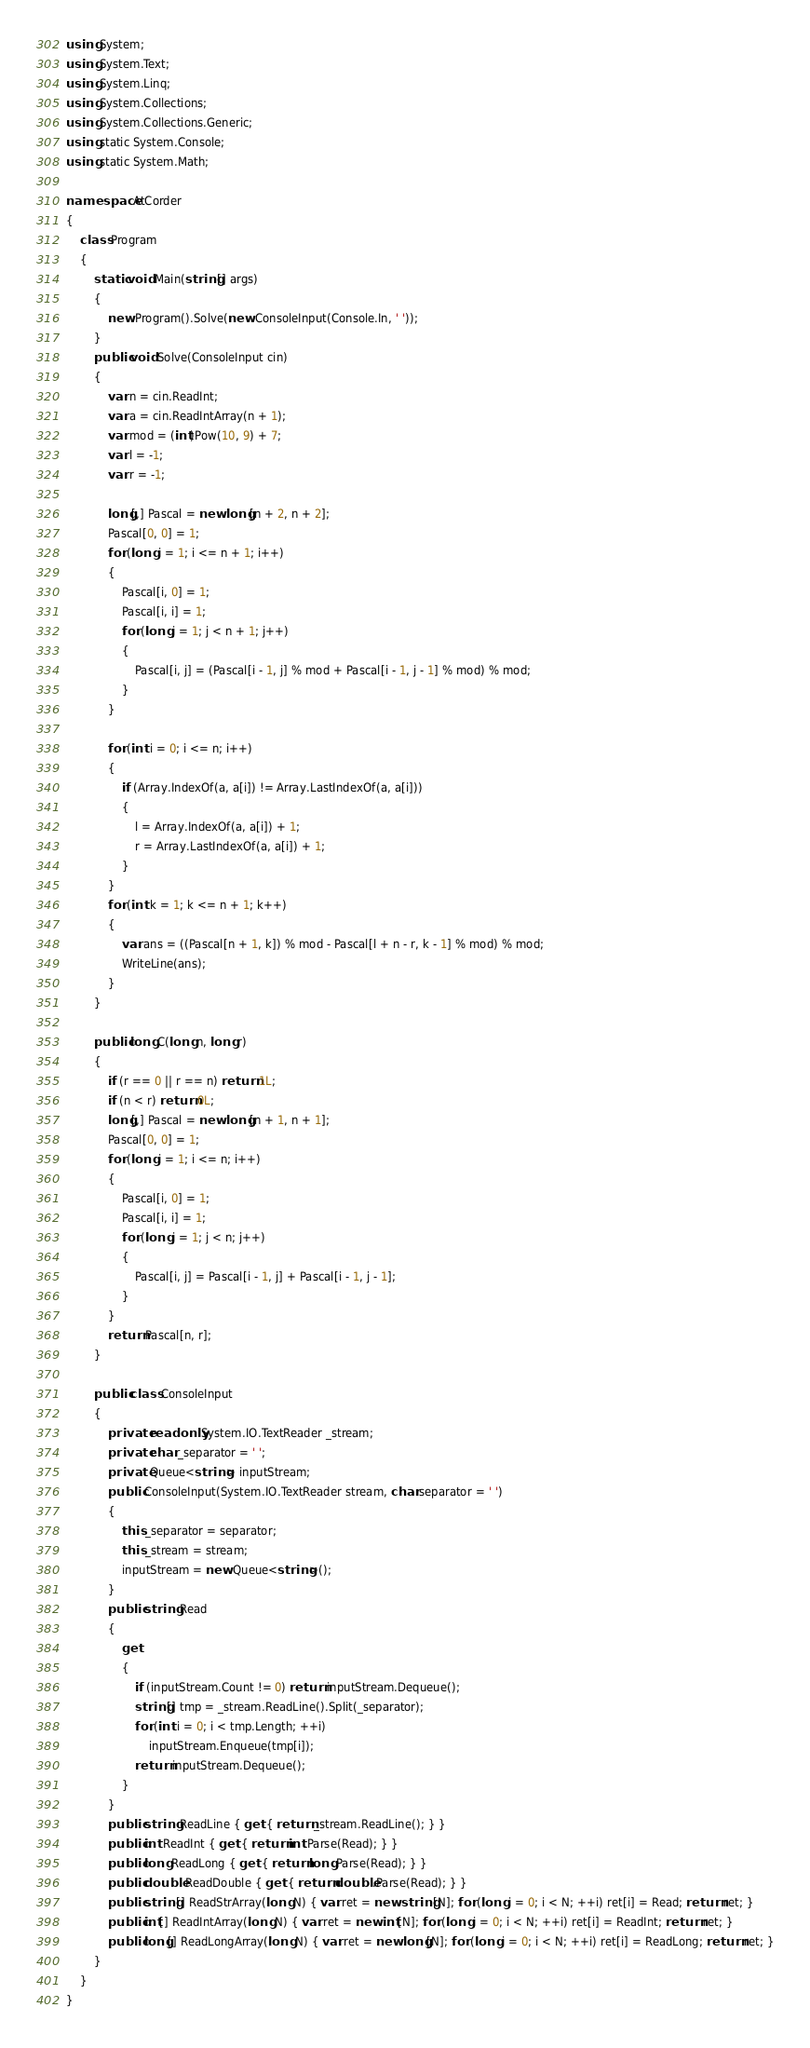Convert code to text. <code><loc_0><loc_0><loc_500><loc_500><_C#_>using System;
using System.Text;
using System.Linq;
using System.Collections;
using System.Collections.Generic;
using static System.Console;
using static System.Math;

namespace AtCorder
{
    class Program
    {
        static void Main(string[] args)
        {
            new Program().Solve(new ConsoleInput(Console.In, ' '));
        }
        public void Solve(ConsoleInput cin)
        {
            var n = cin.ReadInt;
            var a = cin.ReadIntArray(n + 1);
            var mod = (int)Pow(10, 9) + 7;
            var l = -1;
            var r = -1;

            long[,] Pascal = new long[n + 2, n + 2];
            Pascal[0, 0] = 1;
            for (long i = 1; i <= n + 1; i++)
            {
                Pascal[i, 0] = 1;
                Pascal[i, i] = 1;
                for (long j = 1; j < n + 1; j++)
                {
                    Pascal[i, j] = (Pascal[i - 1, j] % mod + Pascal[i - 1, j - 1] % mod) % mod;
                }
            }

            for (int i = 0; i <= n; i++)
            {
                if (Array.IndexOf(a, a[i]) != Array.LastIndexOf(a, a[i]))
                {
                    l = Array.IndexOf(a, a[i]) + 1;
                    r = Array.LastIndexOf(a, a[i]) + 1;
                }
            }
            for (int k = 1; k <= n + 1; k++)
            {
                var ans = ((Pascal[n + 1, k]) % mod - Pascal[l + n - r, k - 1] % mod) % mod;
                WriteLine(ans);
            }
        }

        public long C(long n, long r)
        {
            if (r == 0 || r == n) return 1L;
            if (n < r) return 0L;
            long[,] Pascal = new long[n + 1, n + 1];
            Pascal[0, 0] = 1;
            for (long i = 1; i <= n; i++)
            {
                Pascal[i, 0] = 1;
                Pascal[i, i] = 1;
                for (long j = 1; j < n; j++)
                {
                    Pascal[i, j] = Pascal[i - 1, j] + Pascal[i - 1, j - 1];
                }
            }
            return Pascal[n, r];
        }

        public class ConsoleInput
        {
            private readonly System.IO.TextReader _stream;
            private char _separator = ' ';
            private Queue<string> inputStream;
            public ConsoleInput(System.IO.TextReader stream, char separator = ' ')
            {
                this._separator = separator;
                this._stream = stream;
                inputStream = new Queue<string>();
            }
            public string Read
            {
                get
                {
                    if (inputStream.Count != 0) return inputStream.Dequeue();
                    string[] tmp = _stream.ReadLine().Split(_separator);
                    for (int i = 0; i < tmp.Length; ++i)
                        inputStream.Enqueue(tmp[i]);
                    return inputStream.Dequeue();
                }
            }
            public string ReadLine { get { return _stream.ReadLine(); } }
            public int ReadInt { get { return int.Parse(Read); } }
            public long ReadLong { get { return long.Parse(Read); } }
            public double ReadDouble { get { return double.Parse(Read); } }
            public string[] ReadStrArray(long N) { var ret = new string[N]; for (long i = 0; i < N; ++i) ret[i] = Read; return ret; }
            public int[] ReadIntArray(long N) { var ret = new int[N]; for (long i = 0; i < N; ++i) ret[i] = ReadInt; return ret; }
            public long[] ReadLongArray(long N) { var ret = new long[N]; for (long i = 0; i < N; ++i) ret[i] = ReadLong; return ret; }
        }
    }
}
</code> 